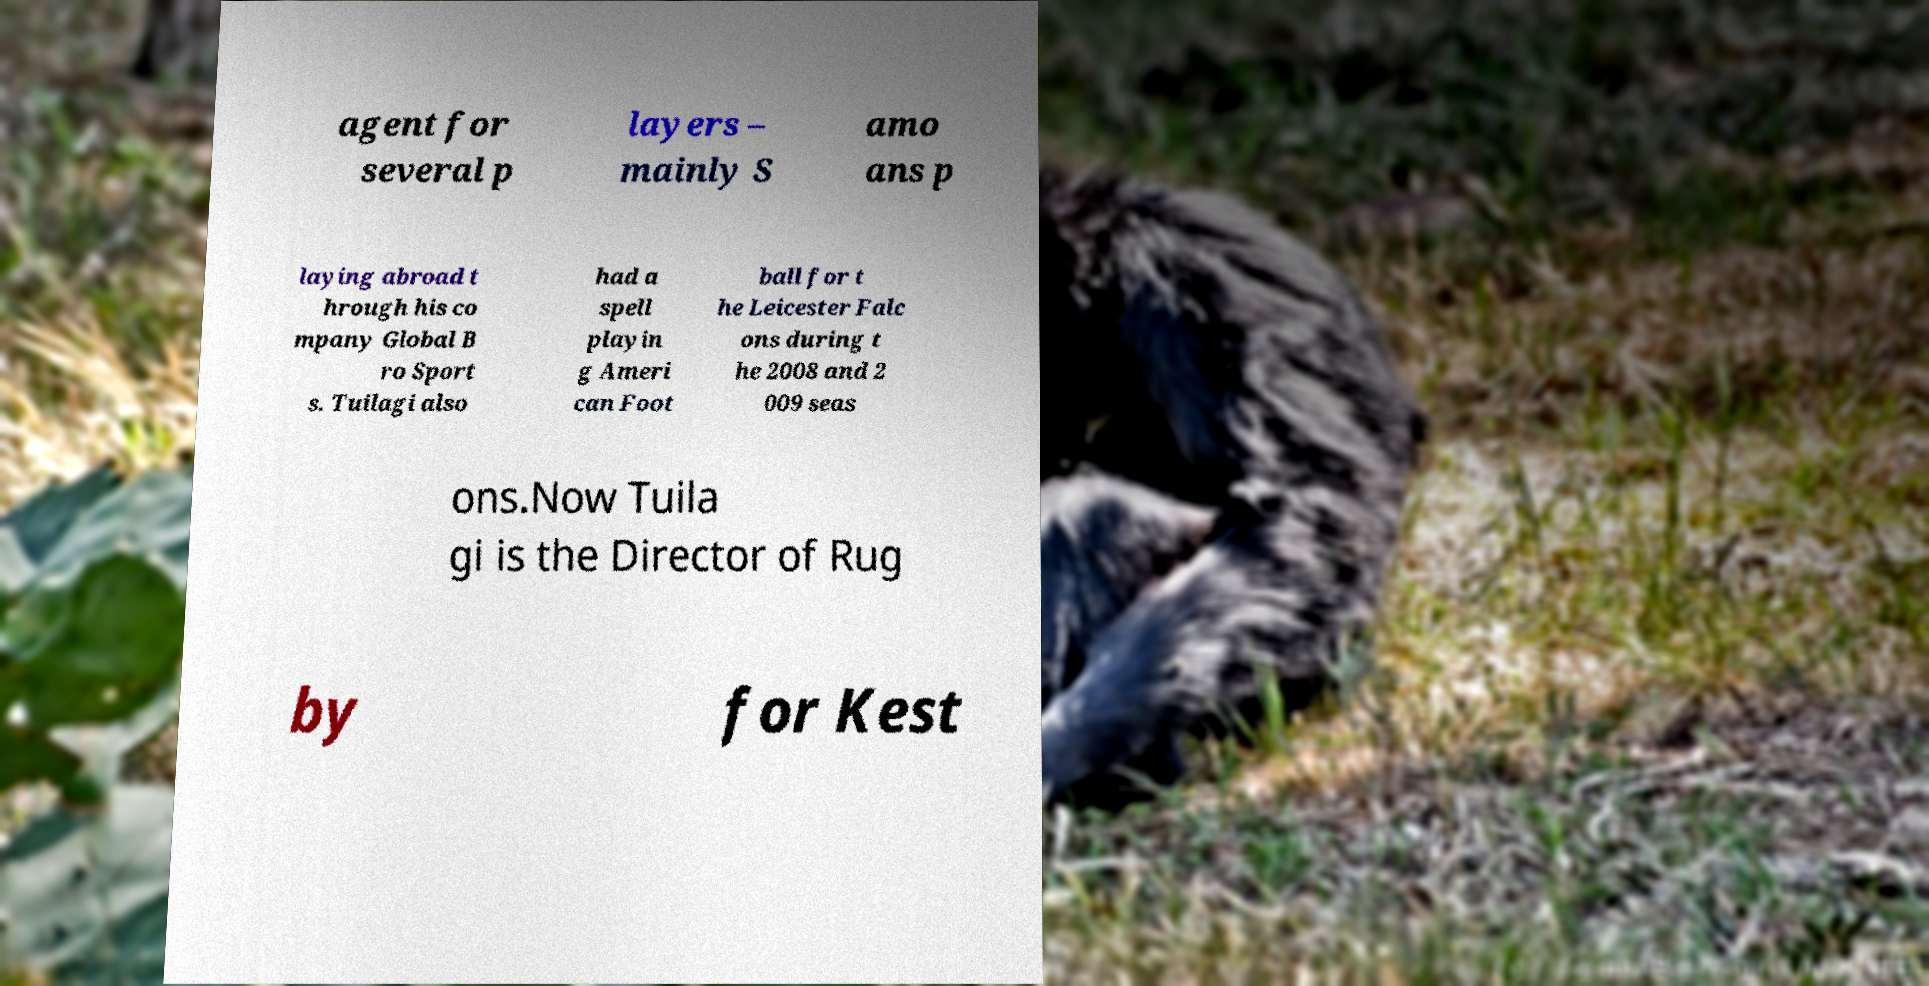Could you extract and type out the text from this image? agent for several p layers – mainly S amo ans p laying abroad t hrough his co mpany Global B ro Sport s. Tuilagi also had a spell playin g Ameri can Foot ball for t he Leicester Falc ons during t he 2008 and 2 009 seas ons.Now Tuila gi is the Director of Rug by for Kest 